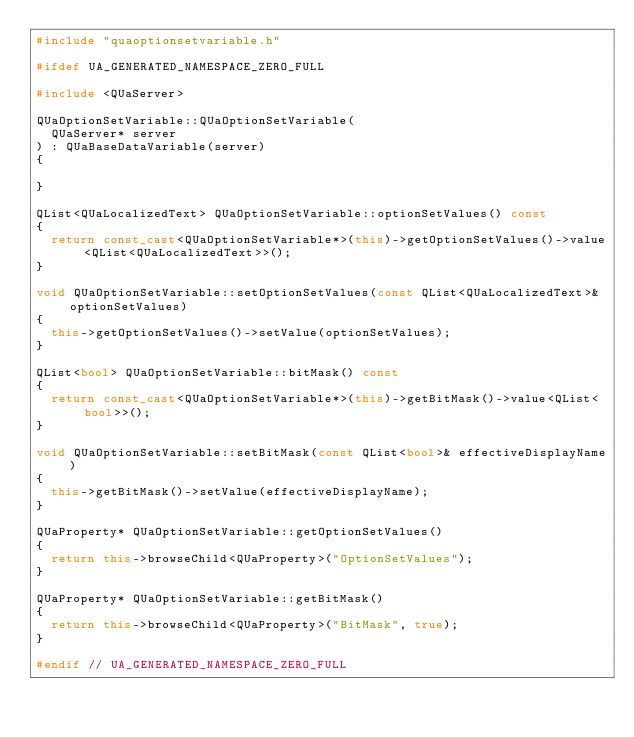<code> <loc_0><loc_0><loc_500><loc_500><_C++_>#include "quaoptionsetvariable.h"

#ifdef UA_GENERATED_NAMESPACE_ZERO_FULL

#include <QUaServer>

QUaOptionSetVariable::QUaOptionSetVariable(
	QUaServer* server
) : QUaBaseDataVariable(server)
{

}

QList<QUaLocalizedText> QUaOptionSetVariable::optionSetValues() const
{
	return const_cast<QUaOptionSetVariable*>(this)->getOptionSetValues()->value<QList<QUaLocalizedText>>();
}

void QUaOptionSetVariable::setOptionSetValues(const QList<QUaLocalizedText>& optionSetValues)
{
	this->getOptionSetValues()->setValue(optionSetValues);
}

QList<bool> QUaOptionSetVariable::bitMask() const
{
	return const_cast<QUaOptionSetVariable*>(this)->getBitMask()->value<QList<bool>>();
}

void QUaOptionSetVariable::setBitMask(const QList<bool>& effectiveDisplayName)
{
	this->getBitMask()->setValue(effectiveDisplayName);
}

QUaProperty* QUaOptionSetVariable::getOptionSetValues()
{
	return this->browseChild<QUaProperty>("OptionSetValues");
}

QUaProperty* QUaOptionSetVariable::getBitMask()
{
	return this->browseChild<QUaProperty>("BitMask", true);
}

#endif // UA_GENERATED_NAMESPACE_ZERO_FULL</code> 